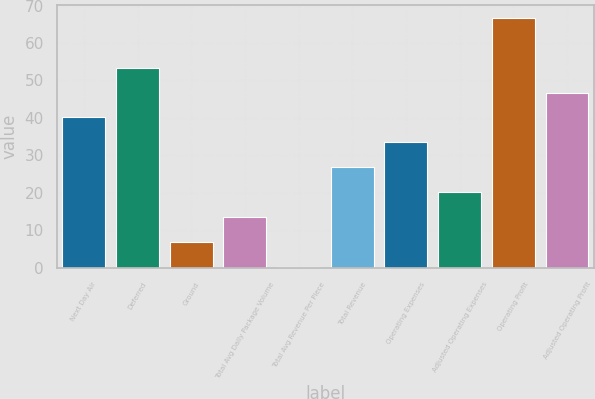<chart> <loc_0><loc_0><loc_500><loc_500><bar_chart><fcel>Next Day Air<fcel>Deferred<fcel>Ground<fcel>Total Avg Daily Package Volume<fcel>Total Avg Revenue Per Piece<fcel>Total Revenue<fcel>Operating Expenses<fcel>Adjusted Operating Expenses<fcel>Operating Profit<fcel>Adjusted Operating Profit<nl><fcel>40.14<fcel>53.42<fcel>6.94<fcel>13.58<fcel>0.3<fcel>26.86<fcel>33.5<fcel>20.22<fcel>66.7<fcel>46.78<nl></chart> 